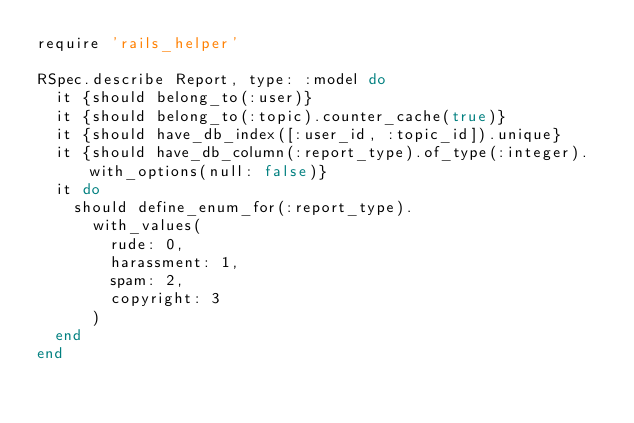Convert code to text. <code><loc_0><loc_0><loc_500><loc_500><_Ruby_>require 'rails_helper'

RSpec.describe Report, type: :model do
  it {should belong_to(:user)}
  it {should belong_to(:topic).counter_cache(true)}
  it {should have_db_index([:user_id, :topic_id]).unique}
  it {should have_db_column(:report_type).of_type(:integer).with_options(null: false)}
  it do
    should define_enum_for(:report_type).
      with_values(
        rude: 0,
        harassment: 1,
        spam: 2,
        copyright: 3
      )
  end
end
</code> 